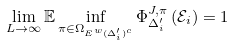Convert formula to latex. <formula><loc_0><loc_0><loc_500><loc_500>\lim _ { L \rightarrow \infty } \mathbb { E } \inf _ { \pi \in \Omega _ { E ^ { w } ( \Delta ^ { \prime } _ { i } ) ^ { c } } } \Phi ^ { J , \pi } _ { \Delta ^ { \prime } _ { i } } \left ( \mathcal { E } _ { i } \right ) = 1</formula> 